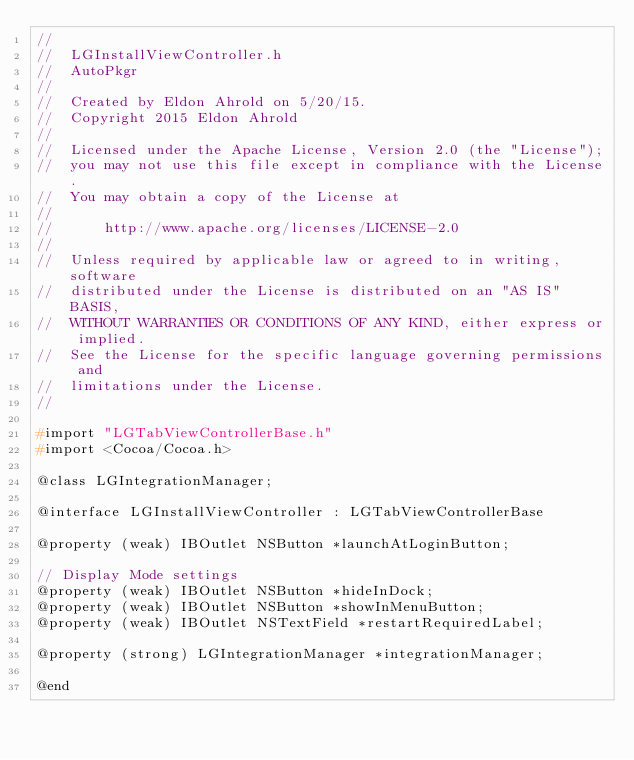Convert code to text. <code><loc_0><loc_0><loc_500><loc_500><_C_>//
//  LGInstallViewController.h
//  AutoPkgr
//
//  Created by Eldon Ahrold on 5/20/15.
//  Copyright 2015 Eldon Ahrold
//
//  Licensed under the Apache License, Version 2.0 (the "License");
//  you may not use this file except in compliance with the License.
//  You may obtain a copy of the License at
//
//      http://www.apache.org/licenses/LICENSE-2.0
//
//  Unless required by applicable law or agreed to in writing, software
//  distributed under the License is distributed on an "AS IS" BASIS,
//  WITHOUT WARRANTIES OR CONDITIONS OF ANY KIND, either express or implied.
//  See the License for the specific language governing permissions and
//  limitations under the License.
//

#import "LGTabViewControllerBase.h"
#import <Cocoa/Cocoa.h>

@class LGIntegrationManager;

@interface LGInstallViewController : LGTabViewControllerBase

@property (weak) IBOutlet NSButton *launchAtLoginButton;

// Display Mode settings
@property (weak) IBOutlet NSButton *hideInDock;
@property (weak) IBOutlet NSButton *showInMenuButton;
@property (weak) IBOutlet NSTextField *restartRequiredLabel;

@property (strong) LGIntegrationManager *integrationManager;

@end
</code> 